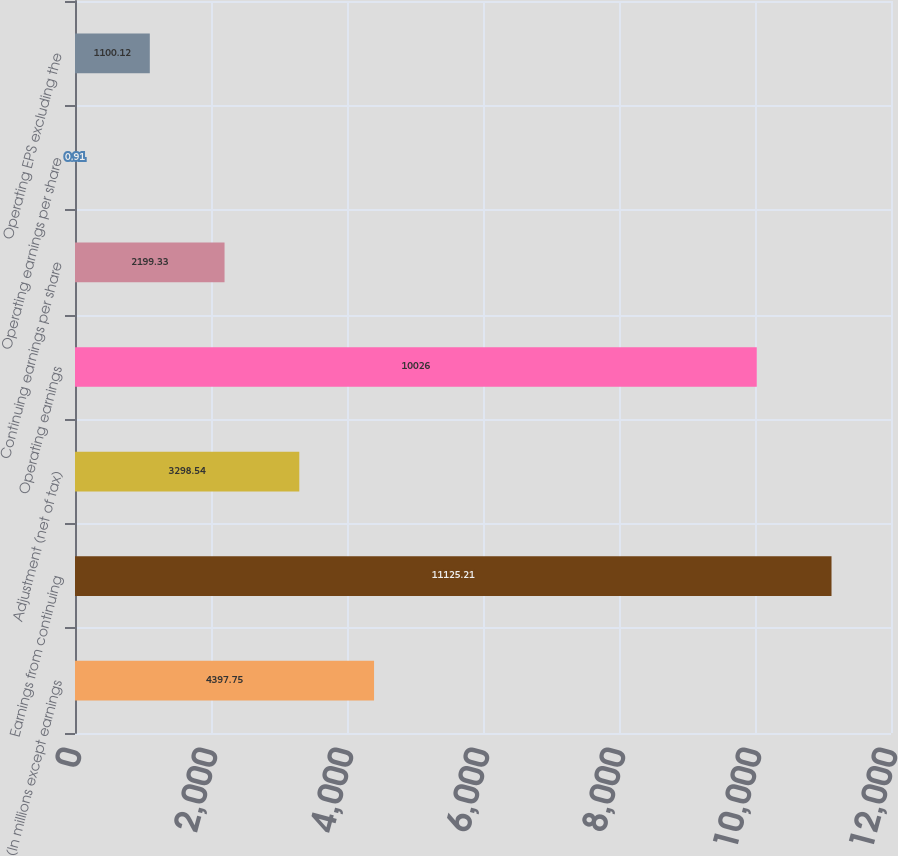Convert chart. <chart><loc_0><loc_0><loc_500><loc_500><bar_chart><fcel>(In millions except earnings<fcel>Earnings from continuing<fcel>Adjustment (net of tax)<fcel>Operating earnings<fcel>Continuing earnings per share<fcel>Operating earnings per share<fcel>Operating EPS excluding the<nl><fcel>4397.75<fcel>11125.2<fcel>3298.54<fcel>10026<fcel>2199.33<fcel>0.91<fcel>1100.12<nl></chart> 